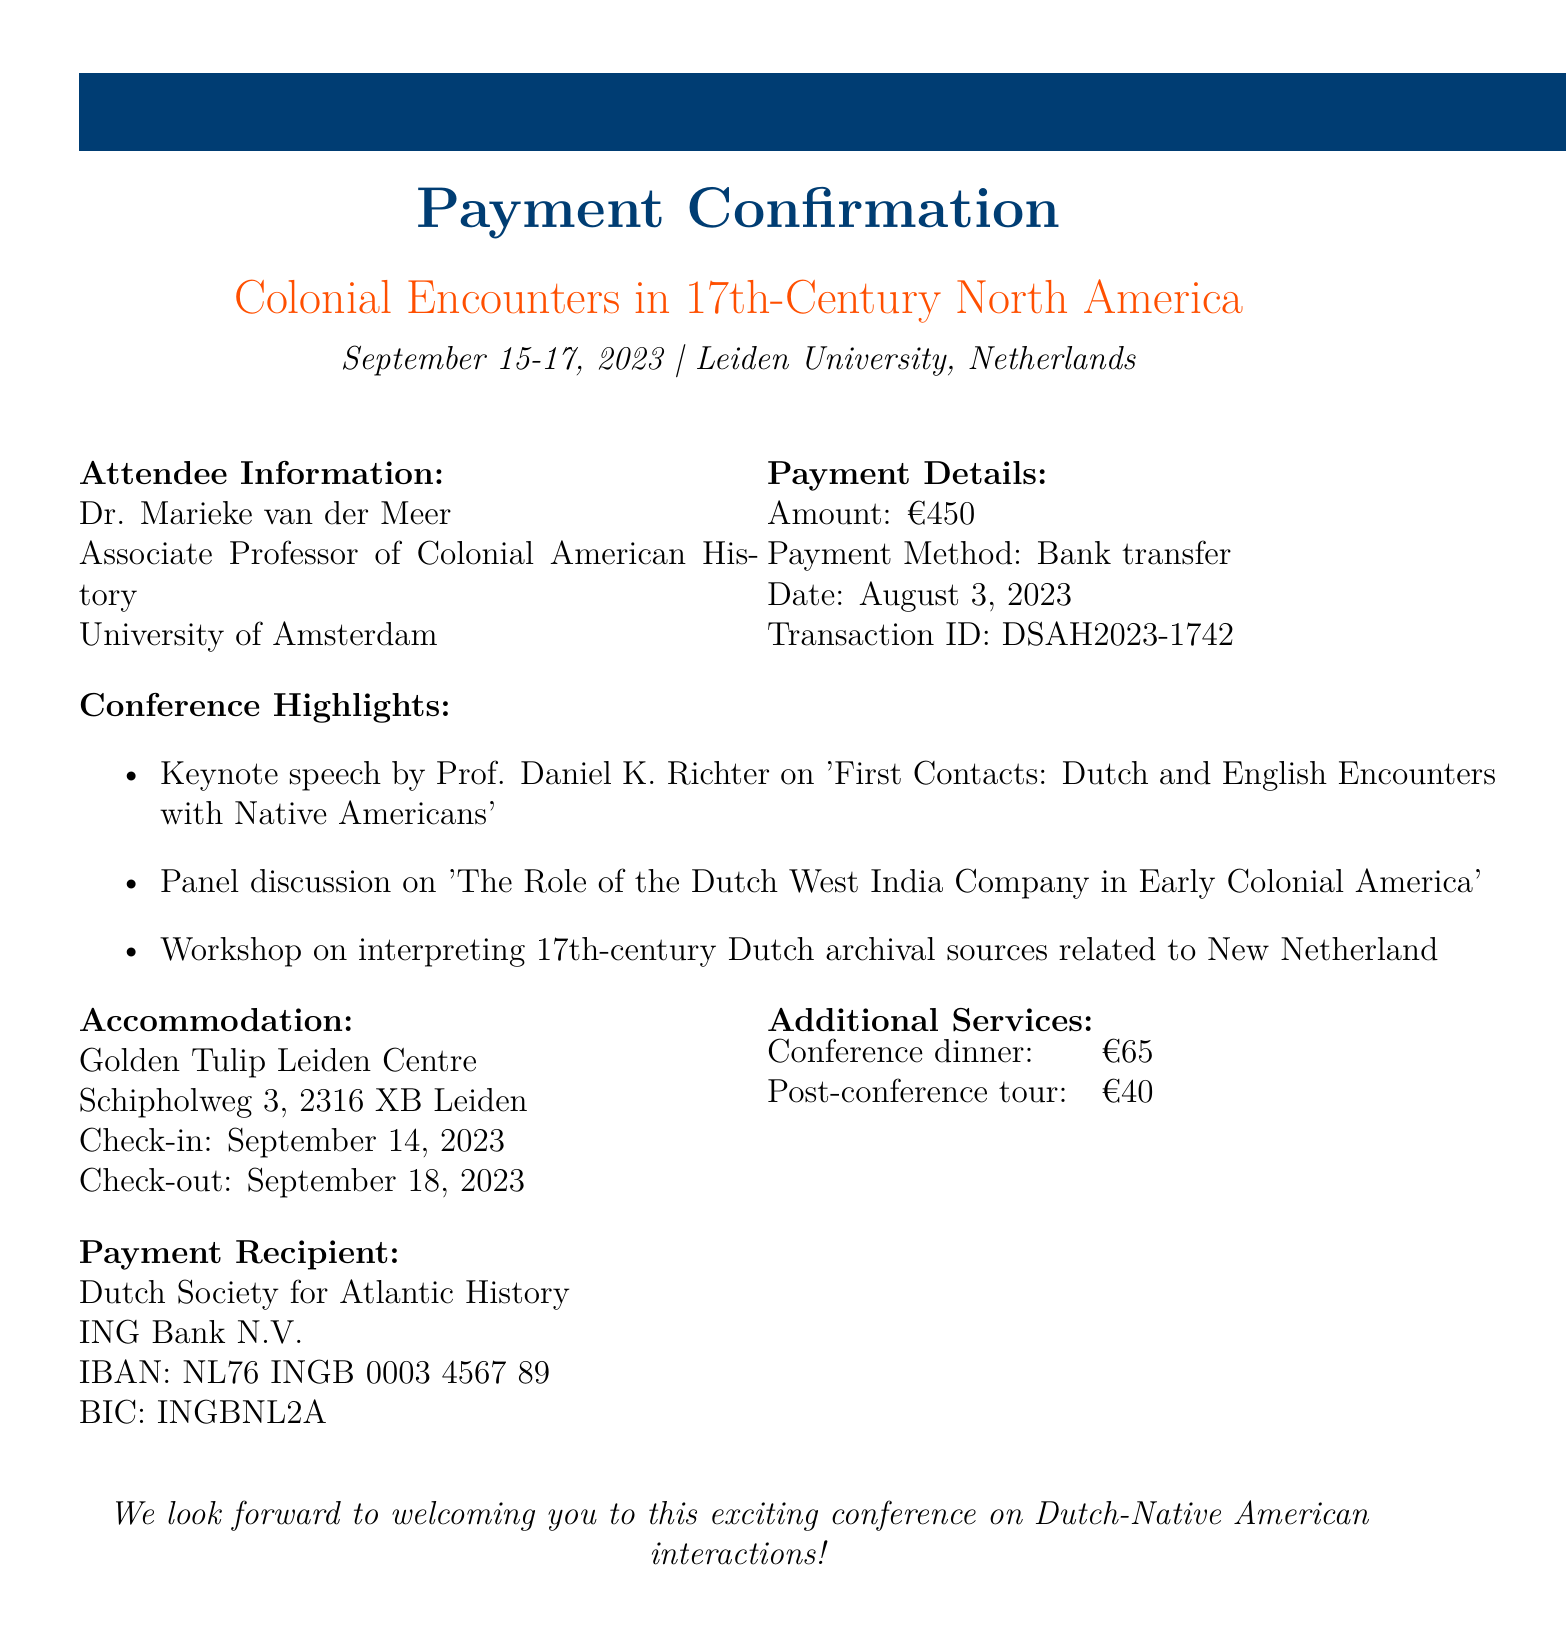What is the date of the conference? The date of the conference is specified in the document as September 15-17, 2023.
Answer: September 15-17, 2023 Who is the organizer of the conference? The organizer's name is mentioned in the document, which is the Dutch Society for Atlantic History.
Answer: Dutch Society for Atlantic History What is the total amount paid for the conference? The amount paid for the conference is stated in the payment details as €450.
Answer: €450 What is the transaction ID for the payment? The transaction ID is provided in the payment details section of the document as DSAH2023-1742.
Answer: DSAH2023-1742 Where is the conference being held? The venue is mentioned in the document as Leiden University, Netherlands.
Answer: Leiden University, Netherlands Which hotel is recommended for accommodation? The document specifies the hotel as Golden Tulip Leiden Centre for accommodation during the conference.
Answer: Golden Tulip Leiden Centre What is the cost of the conference dinner? The cost for the conference dinner is listed in the additional services section as €65.
Answer: €65 What is one highlight of the conference? A highlight is the keynote speech by Prof. Daniel K. Richter on 'First Contacts: Dutch and English Encounters with Native Americans.'
Answer: Keynote speech by Prof. Daniel K. Richter Why is this conference significant for a historian? The conference focuses on Dutch-Native American interactions, which is critical for understanding colonial history.
Answer: Dutch-Native American interactions 